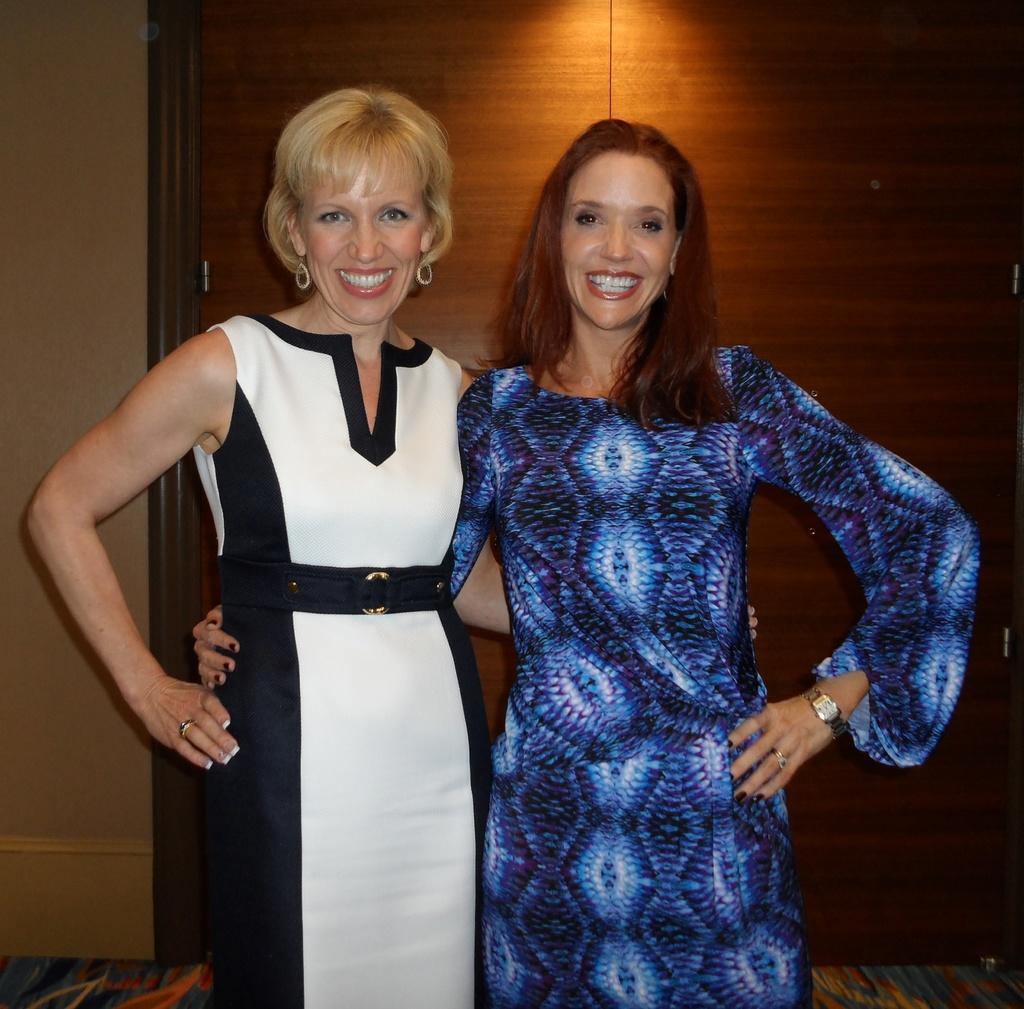How many people are in the image? There are two women in the image. What are the women doing in the image? The women are standing and holding each other. What can be seen in the background of the image? There is a wall and a wooden door visible in the background of the image. What type of wire is hanging from the branch in the image? There is no wire or branch present in the image. What is the income of the women in the image? The income of the women cannot be determined from the image. 